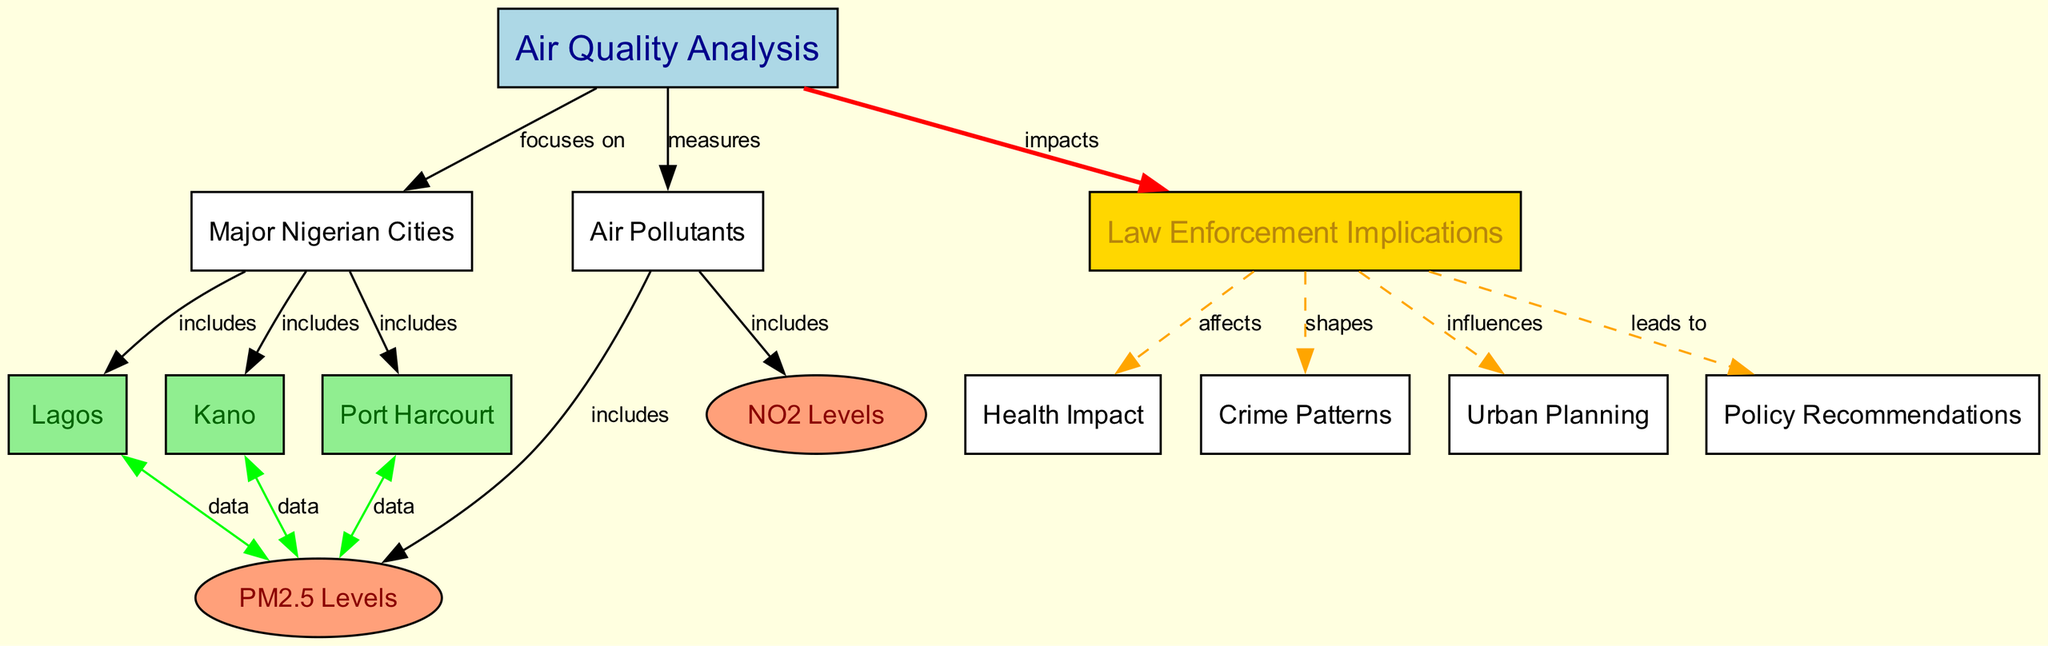What are the three major Nigerian cities included in the air quality analysis? The diagram lists three major Nigerian cities connected to the node "Major Nigerian Cities": Lagos, Kano, and Port Harcourt. These cities are directly linked to the node, indicating their inclusion in the analysis.
Answer: Lagos, Kano, Port Harcourt What type of pollutants are measured in the air quality analysis? The diagram indicates that "Air Quality Analysis" measures "Air Pollutants." Under this node, two specific types of pollutants are mentioned: PM2.5 and NO2 levels, showing that these are key components of the analysis.
Answer: Air Pollutants Which air pollutant is specifically represented as an ellipse in the diagram? The diagram includes two pollutants that are represented as ellipses: PM2.5 Levels and NO2 Levels. The question specifically asks for one, which can be inferred from the visual representation. Both are represented visually, but if I had to choose one, it would be PM2.5 Levels for the first option.
Answer: PM2.5 Levels How does air quality analysis impact law enforcement implications? The diagram shows a direct edge from "Air Quality Analysis" to "Law Enforcement Implications," indicating a direct impact. Additionally, it is illustrated that law enforcement implications affect health impact, crime patterns, urban planning, and leads to policy recommendations, outlining a broader impact chain.
Answer: Impacts What leads to policy recommendations in the context of air quality? The diagram illustrates that "Law Enforcement Implications" leads to "Policy Recommendations." This indicates a causative relationship whereby insights and findings related to law enforcement based on air quality data inform policy recommendations.
Answer: Law Enforcement Implications Which air pollutant data is specifically documented in Lagos? The diagram connects Lagos directly to PM2.5 Levels, indicating that PM2.5 data is documented and quantified in the air quality analysis for that city.
Answer: PM2.5 Levels What health implications are affected by law enforcement? The diagram specifies that law enforcement implications "affect" health impacts. The relationship shows that understanding air quality helps law enforcement shape policies that may impact public health.
Answer: Health Impact How many edges are connected to the "Law Enforcement Implications" node? By counting the connections leading from the "Law Enforcement Implications" node, we identify five distinct edges connecting to the nodes of Health Impact, Crime Patterns, Urban Planning, and Policy Recommendations.
Answer: Five 